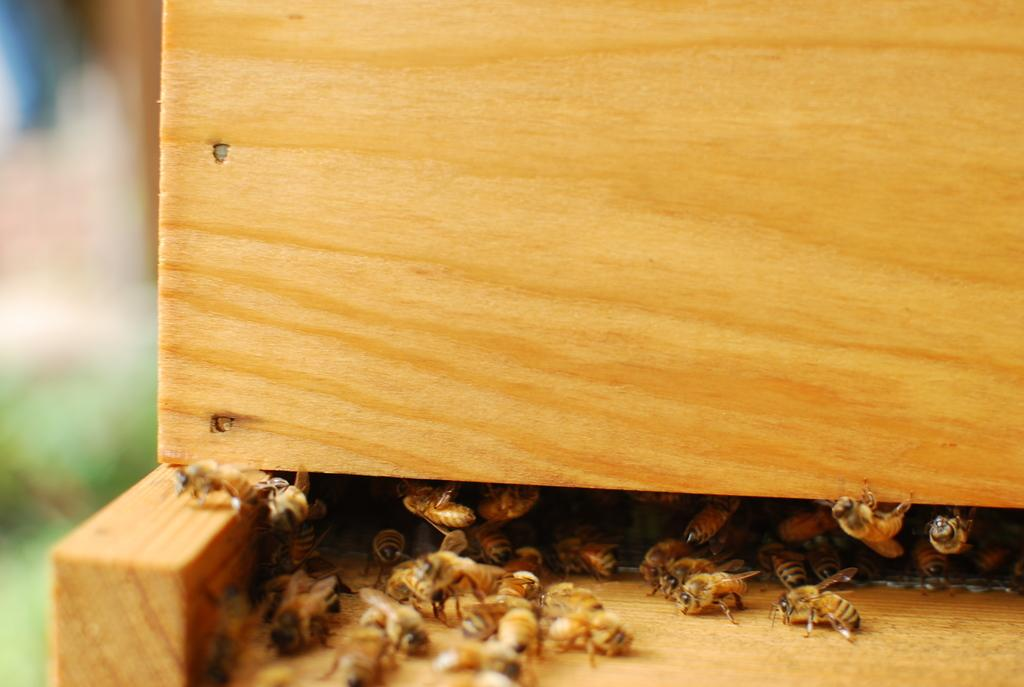What type of insects are present in the image? There are honey bees in the image. Where are the honey bees located? The honey bees are in a wooden box. What type of jewel can be seen in the image? There is no jewel present in the image; it features honey bees in a wooden box. How many airplanes are visible in the image? There are no airplanes present in the image. 